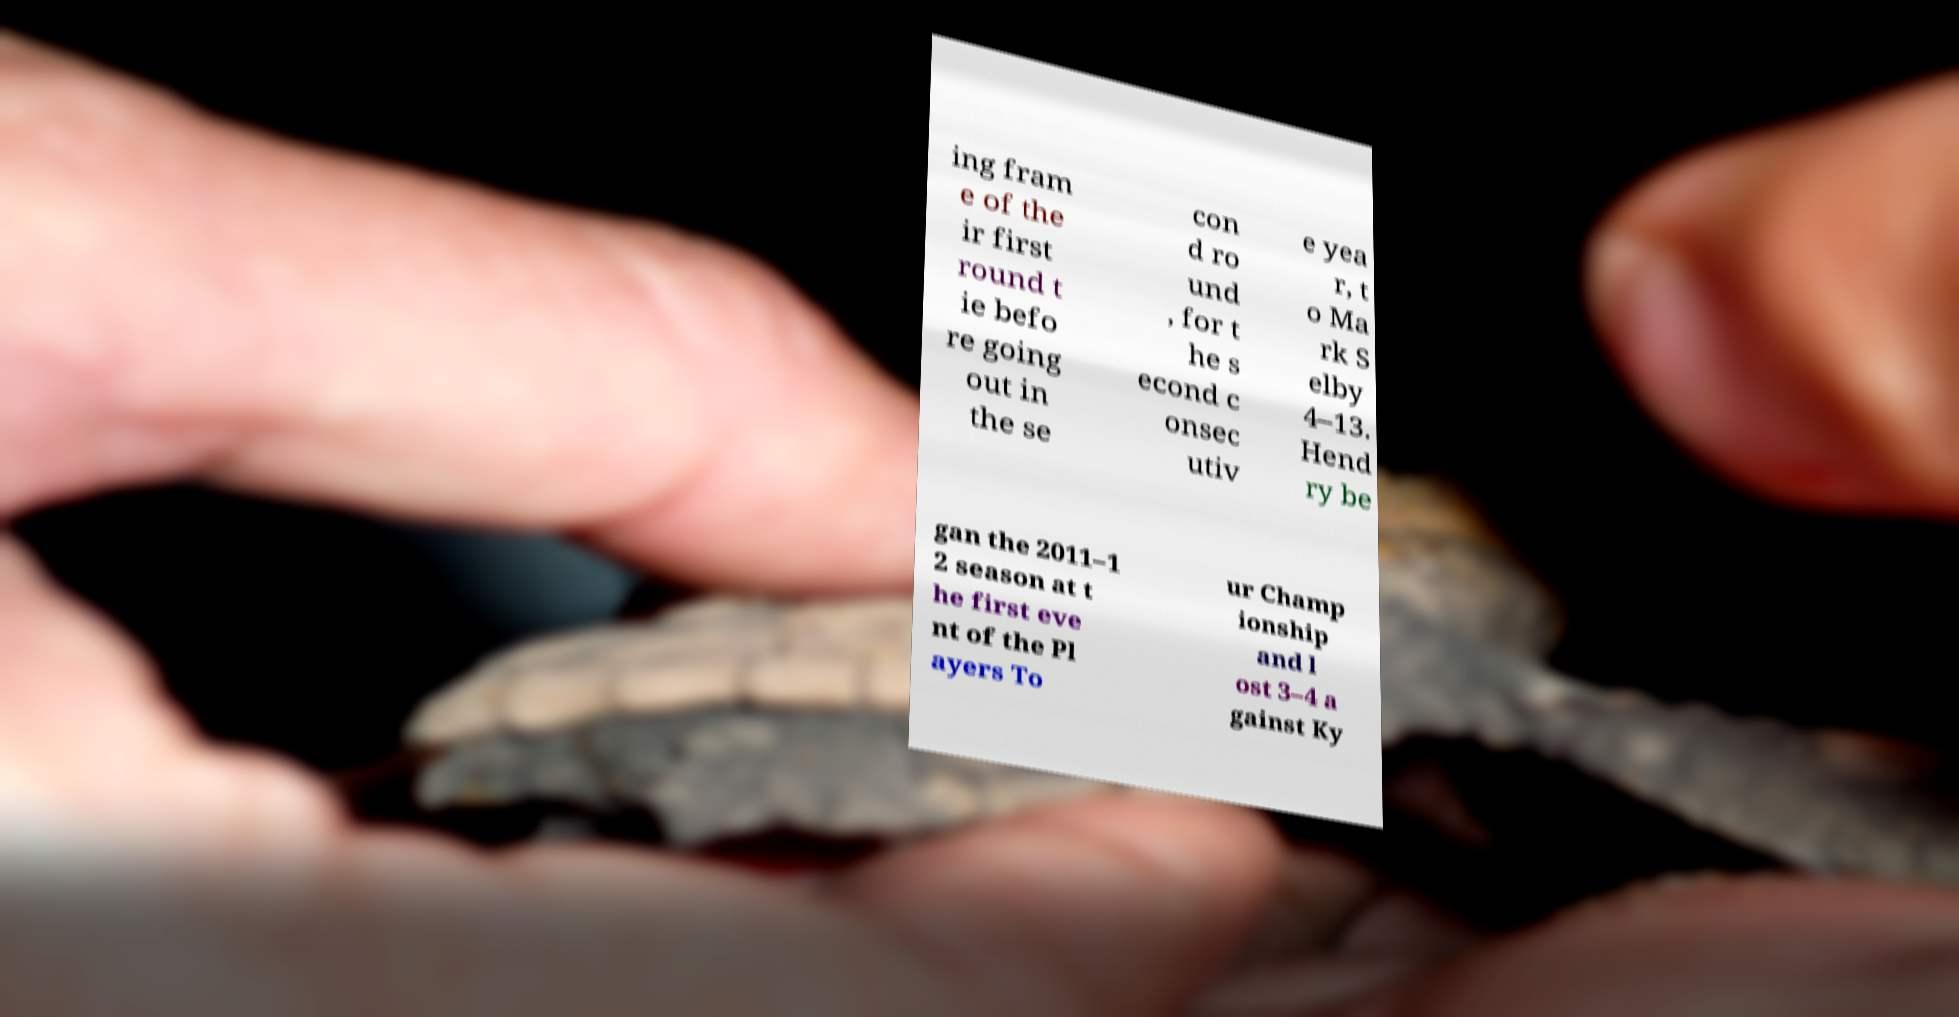For documentation purposes, I need the text within this image transcribed. Could you provide that? ing fram e of the ir first round t ie befo re going out in the se con d ro und , for t he s econd c onsec utiv e yea r, t o Ma rk S elby 4–13. Hend ry be gan the 2011–1 2 season at t he first eve nt of the Pl ayers To ur Champ ionship and l ost 3–4 a gainst Ky 